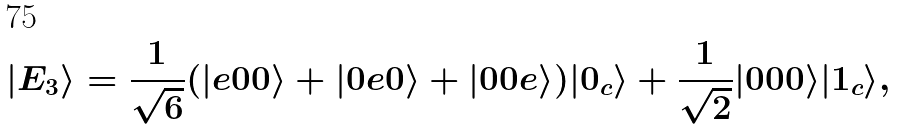Convert formula to latex. <formula><loc_0><loc_0><loc_500><loc_500>| E _ { 3 } \rangle = \frac { 1 } { \sqrt { 6 } } ( | e 0 0 \rangle + | 0 e 0 \rangle + | 0 0 e \rangle ) | 0 _ { c } \rangle + \frac { 1 } { \sqrt { 2 } } | 0 0 0 \rangle | 1 _ { c } \rangle ,</formula> 